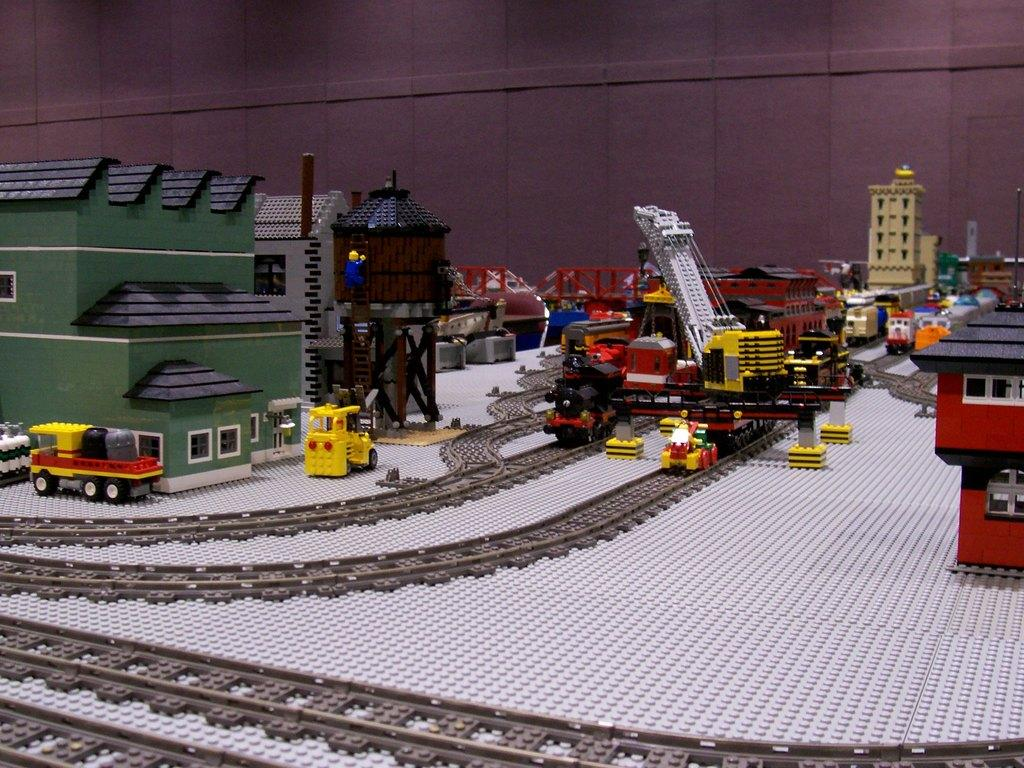What type of toys are present in the image? There are toy houses, toy vehicles, and a toy bridge in the image. Are there any other types of toys visible in the image? Yes, there are toy railway tracks in the image. What is the surface on which the toys are placed? There is ground visible in the image. Is there any other structural element visible in the image? Yes, there is a wall visible in the image. What type of food is being served on the toy bridge in the image? There is no food present in the image, and the toy bridge is not serving any food. 